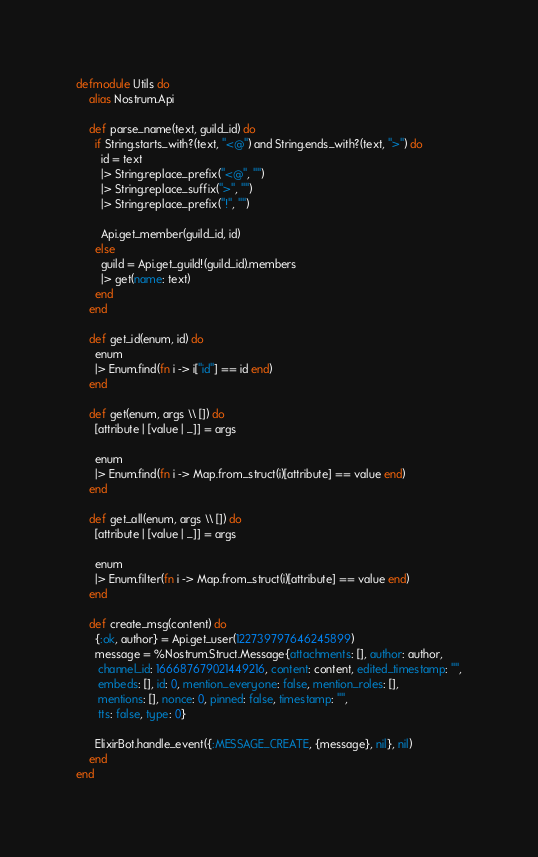Convert code to text. <code><loc_0><loc_0><loc_500><loc_500><_Elixir_>defmodule Utils do
    alias Nostrum.Api

    def parse_name(text, guild_id) do
      if String.starts_with?(text, "<@") and String.ends_with?(text, ">") do
        id = text
        |> String.replace_prefix("<@", "")
        |> String.replace_suffix(">", "")
        |> String.replace_prefix("!", "")

        Api.get_member(guild_id, id)
      else
        guild = Api.get_guild!(guild_id).members
        |> get(name: text)
      end
    end

    def get_id(enum, id) do
      enum
      |> Enum.find(fn i -> i["id"] == id end)
    end

    def get(enum, args \\ []) do
      [attribute | [value | _]] = args

      enum
      |> Enum.find(fn i -> Map.from_struct(i)[attribute] == value end)
    end

    def get_all(enum, args \\ []) do
      [attribute | [value | _]] = args

      enum
      |> Enum.filter(fn i -> Map.from_struct(i)[attribute] == value end)
    end

    def create_msg(content) do
      {:ok, author} = Api.get_user(122739797646245899)
      message = %Nostrum.Struct.Message{attachments: [], author: author,
       channel_id: 166687679021449216, content: content, edited_timestamp: "",
       embeds: [], id: 0, mention_everyone: false, mention_roles: [],
       mentions: [], nonce: 0, pinned: false, timestamp: "",
       tts: false, type: 0}

      ElixirBot.handle_event({:MESSAGE_CREATE, {message}, nil}, nil)
    end
end
</code> 